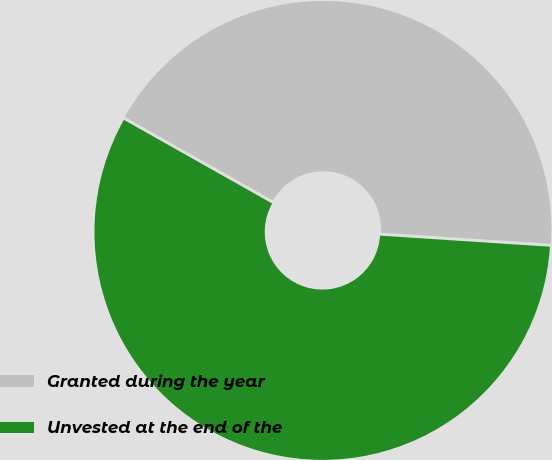Convert chart. <chart><loc_0><loc_0><loc_500><loc_500><pie_chart><fcel>Granted during the year<fcel>Unvested at the end of the<nl><fcel>42.86%<fcel>57.14%<nl></chart> 